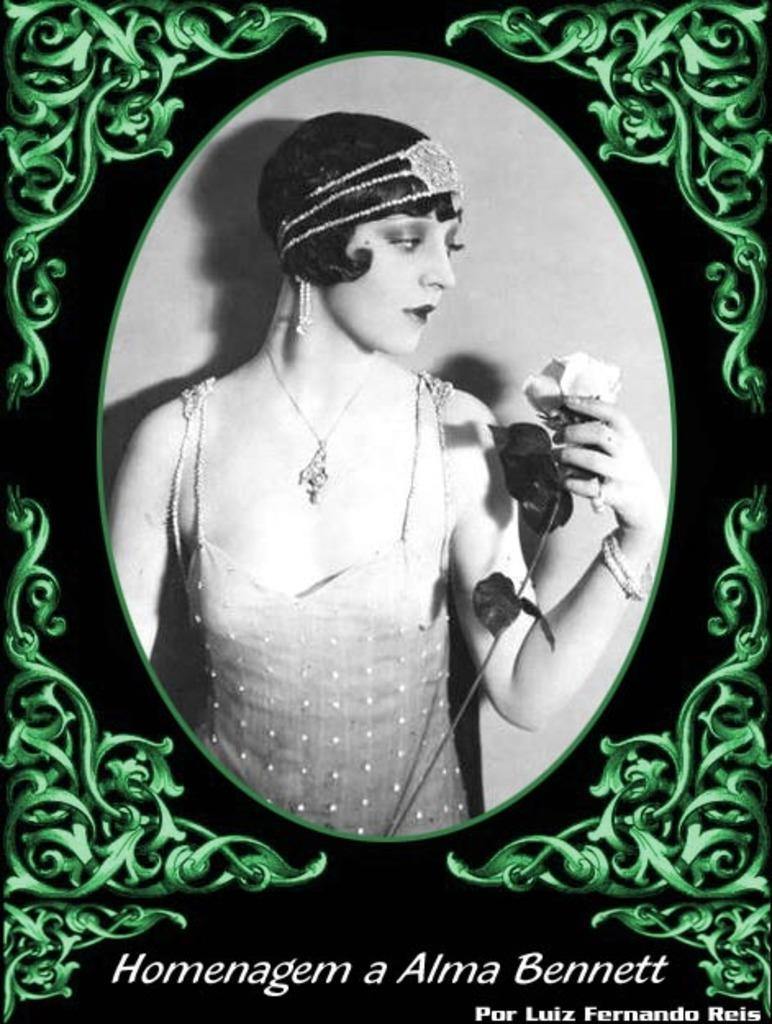How would you summarize this image in a sentence or two? In the image in the center we can see one poster. On the poster,we can see some design and one person standing and holding some object. And we can see something written on the poster. 